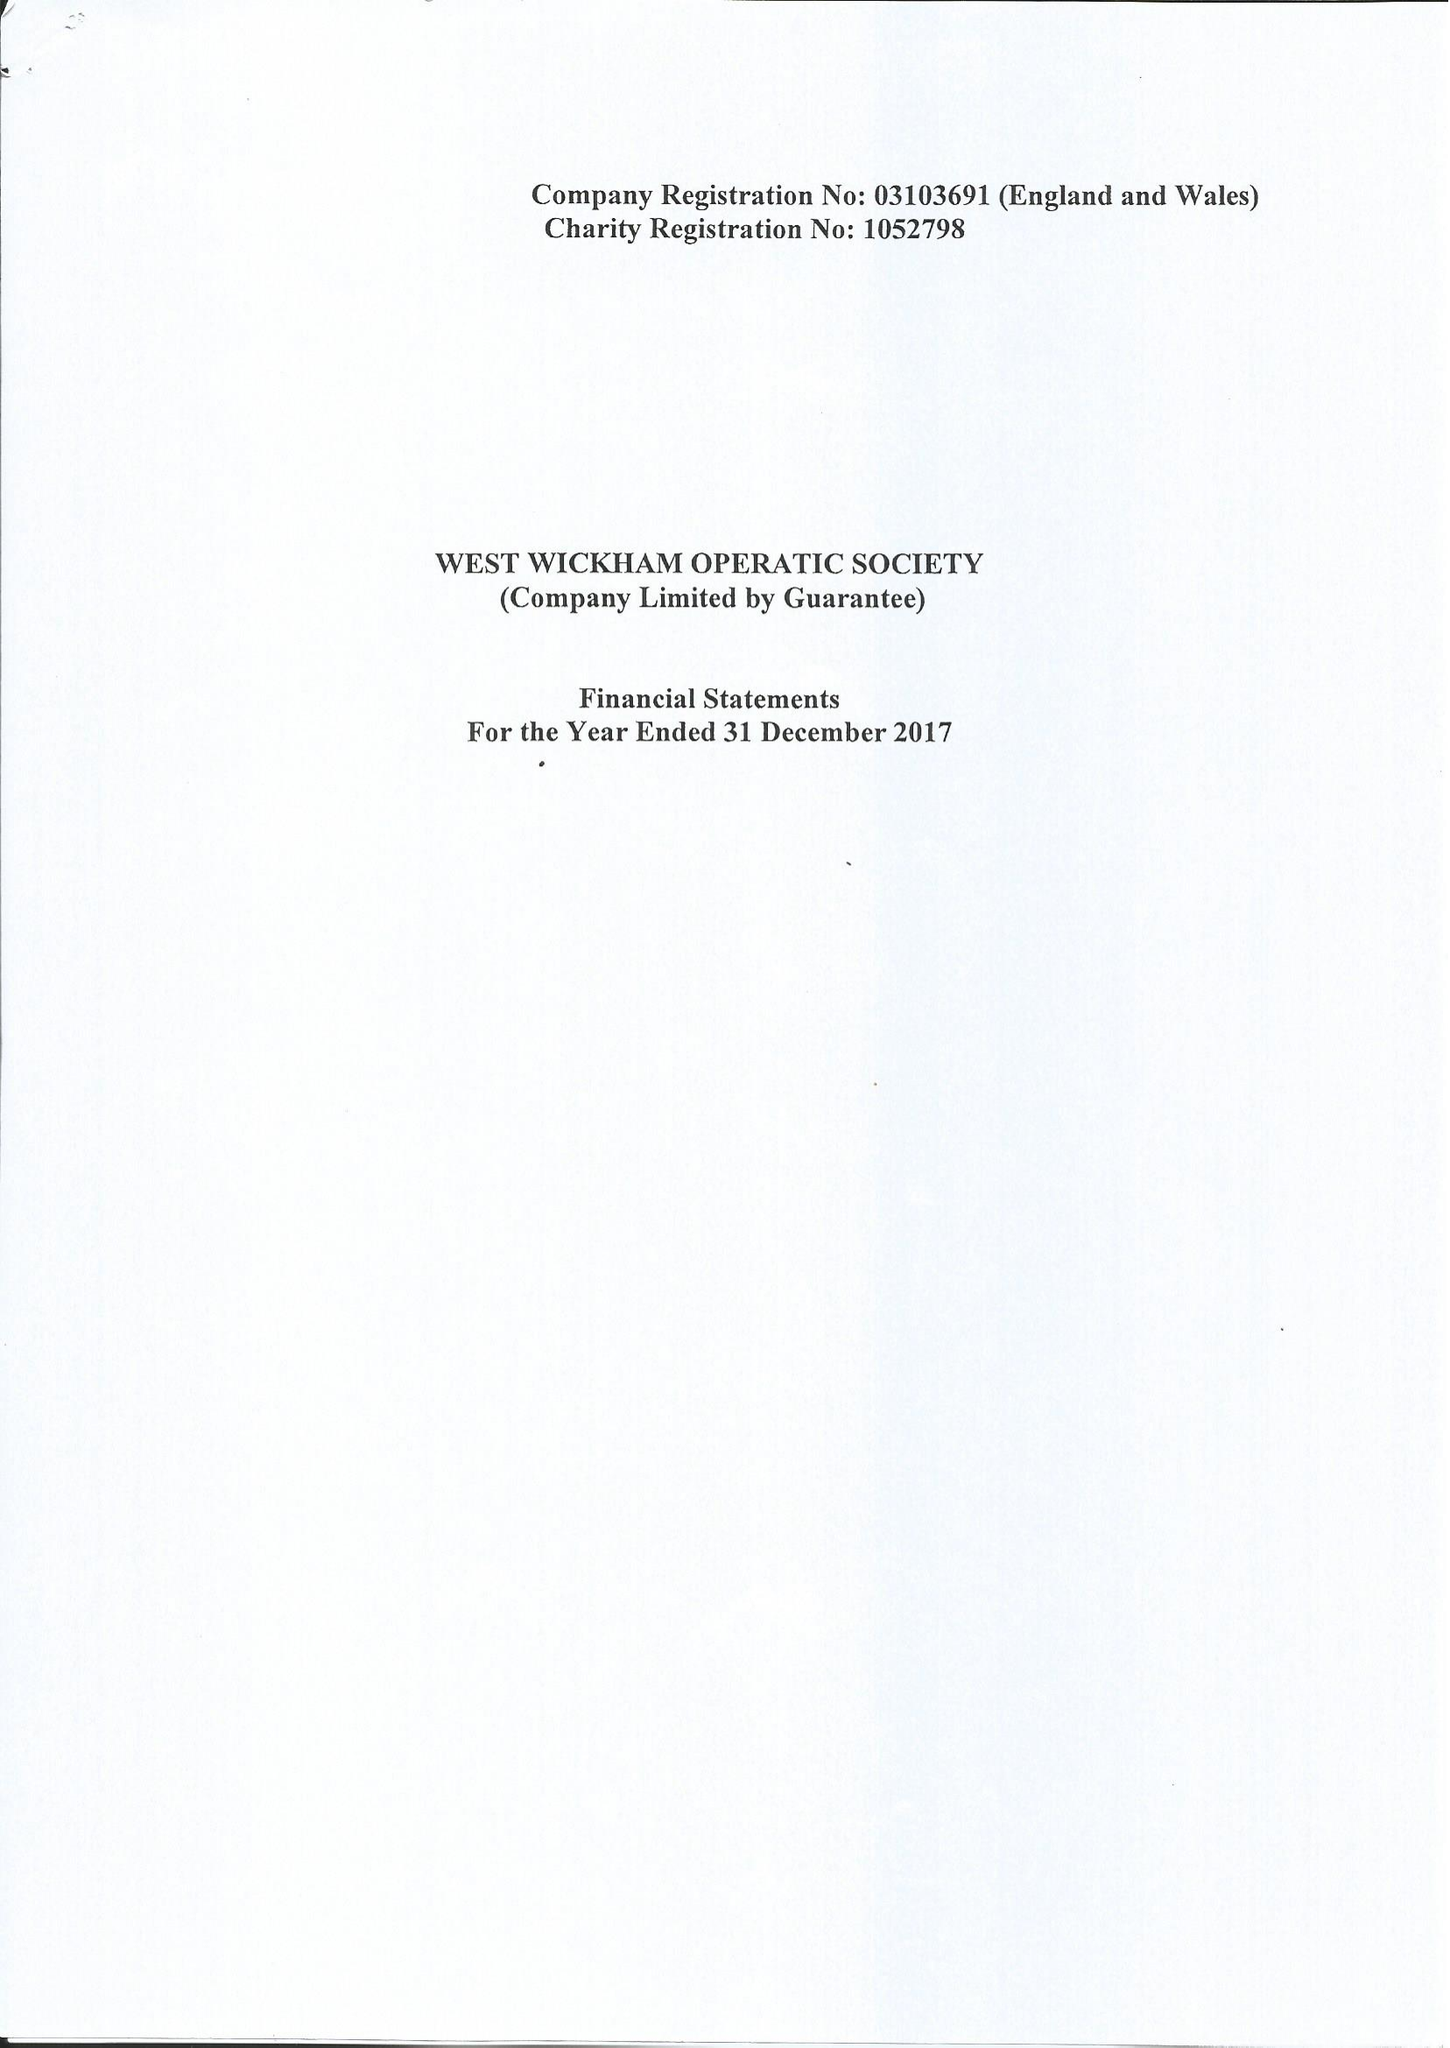What is the value for the spending_annually_in_british_pounds?
Answer the question using a single word or phrase. 126502.00 